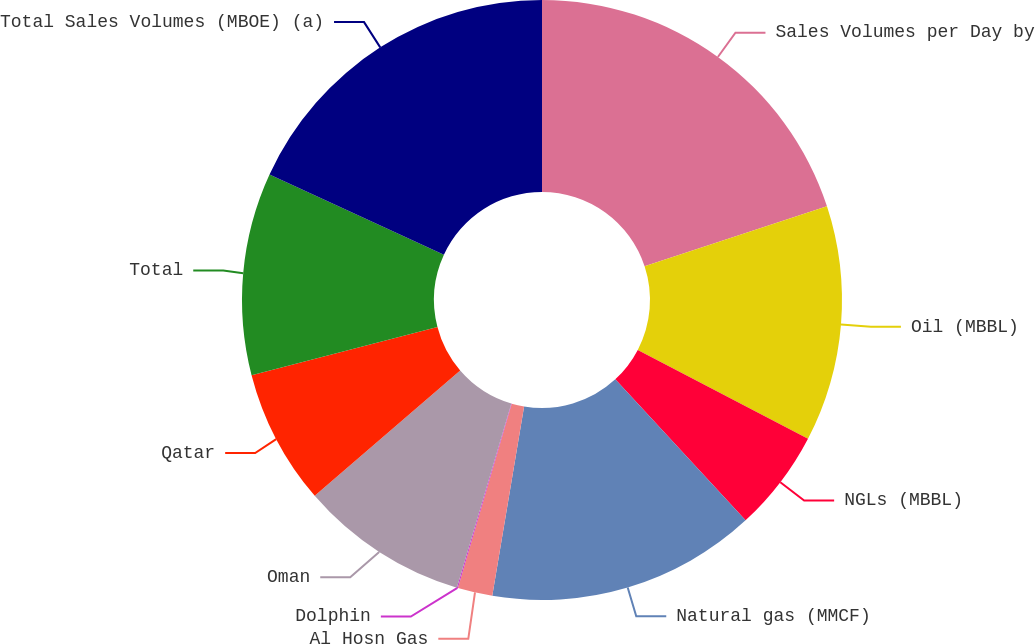Convert chart. <chart><loc_0><loc_0><loc_500><loc_500><pie_chart><fcel>Sales Volumes per Day by<fcel>Oil (MBBL)<fcel>NGLs (MBBL)<fcel>Natural gas (MMCF)<fcel>Al Hosn Gas<fcel>Dolphin<fcel>Oman<fcel>Qatar<fcel>Total<fcel>Total Sales Volumes (MBOE) (a)<nl><fcel>19.94%<fcel>12.71%<fcel>5.48%<fcel>14.52%<fcel>1.87%<fcel>0.06%<fcel>9.1%<fcel>7.29%<fcel>10.9%<fcel>18.13%<nl></chart> 